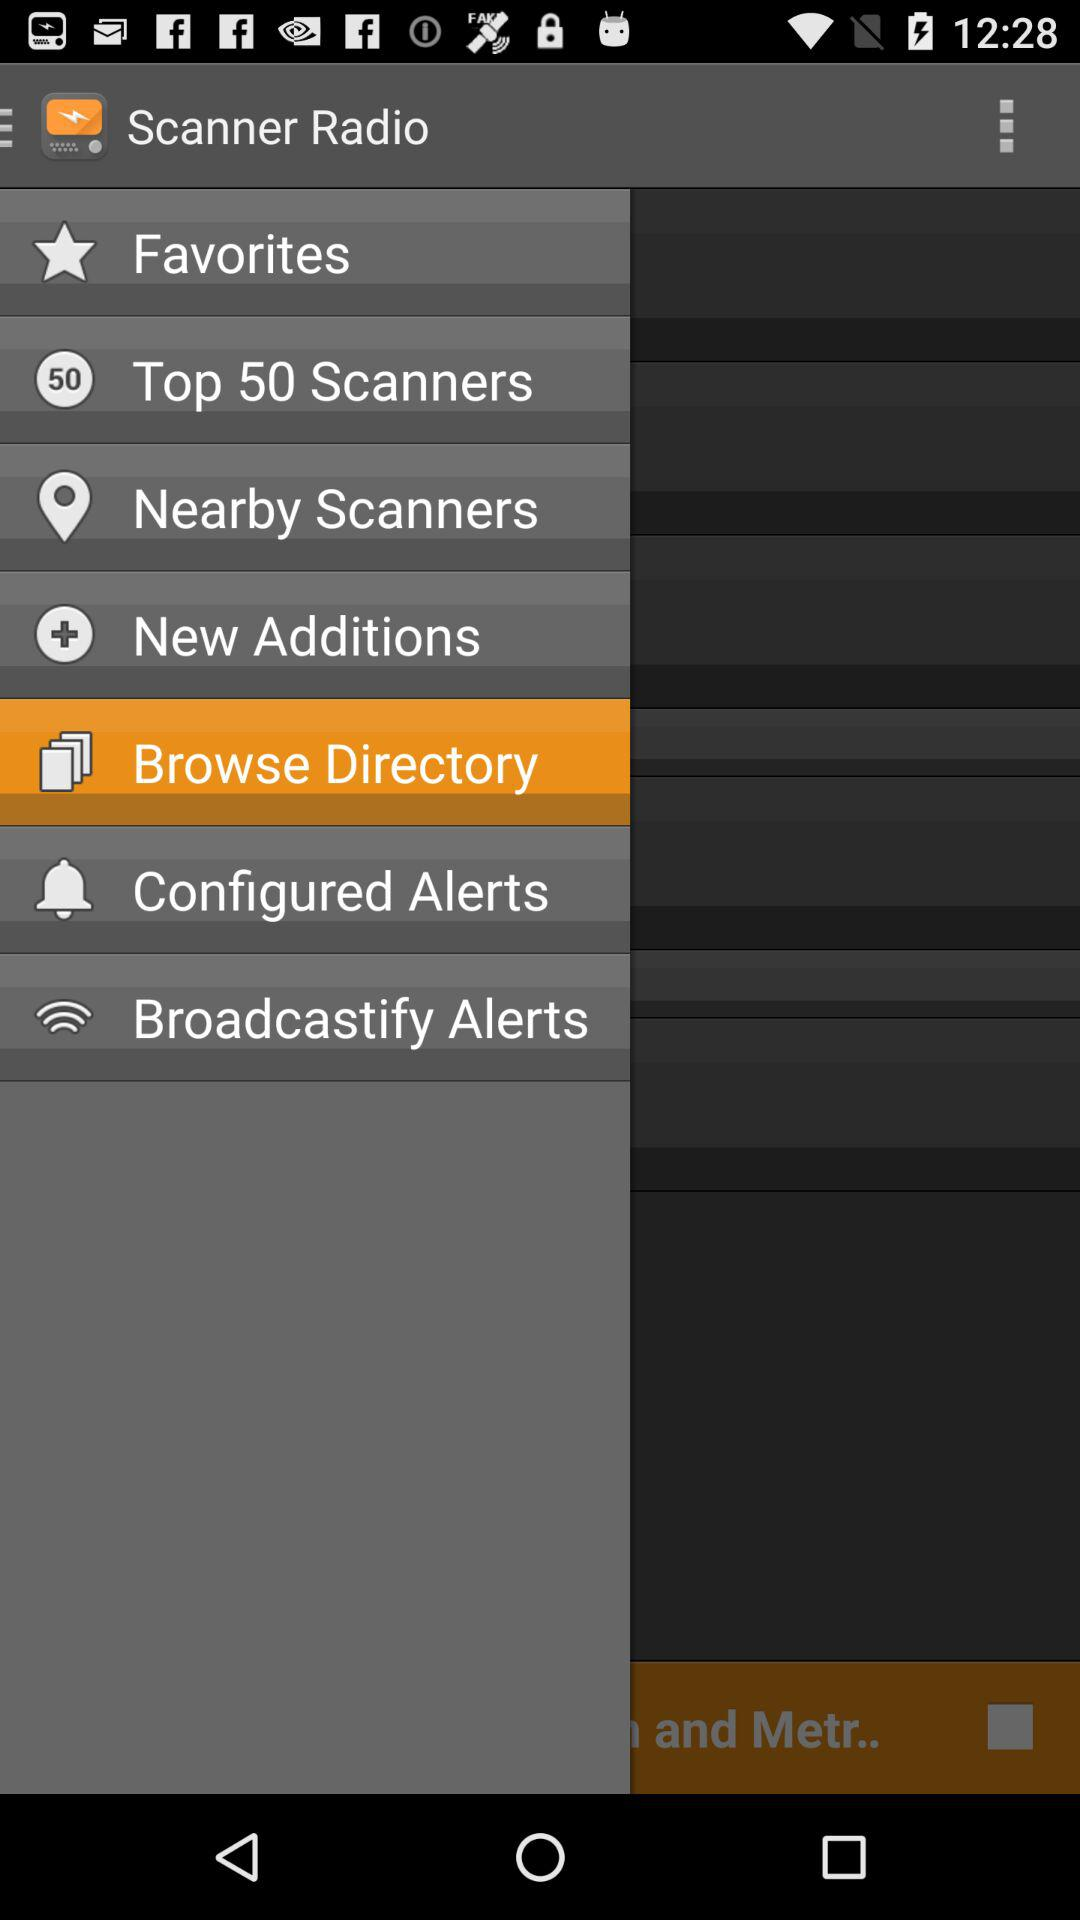What is the application name? The application name is "Scanner Radio". 